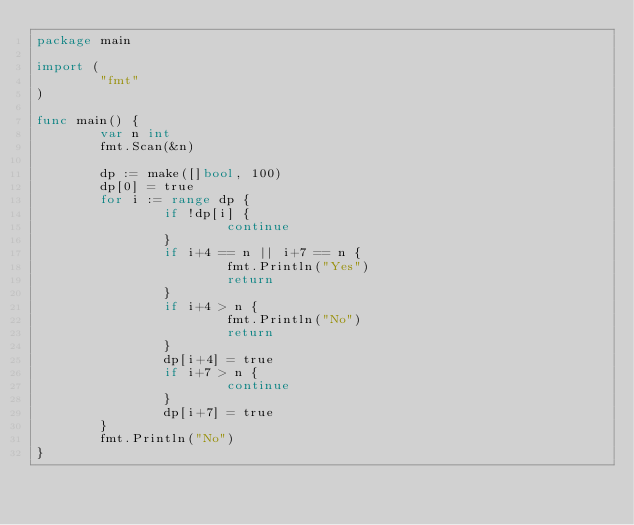<code> <loc_0><loc_0><loc_500><loc_500><_Go_>package main

import (
        "fmt"
)

func main() {
        var n int
        fmt.Scan(&n)

        dp := make([]bool, 100)
        dp[0] = true
        for i := range dp {
                if !dp[i] {
                        continue
                }
                if i+4 == n || i+7 == n {
                        fmt.Println("Yes")
                        return
                }
                if i+4 > n {
                        fmt.Println("No")
                        return
                }
                dp[i+4] = true
                if i+7 > n {
                        continue
                }
                dp[i+7] = true
        }
        fmt.Println("No")
}</code> 